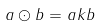<formula> <loc_0><loc_0><loc_500><loc_500>a \odot b = a k b</formula> 